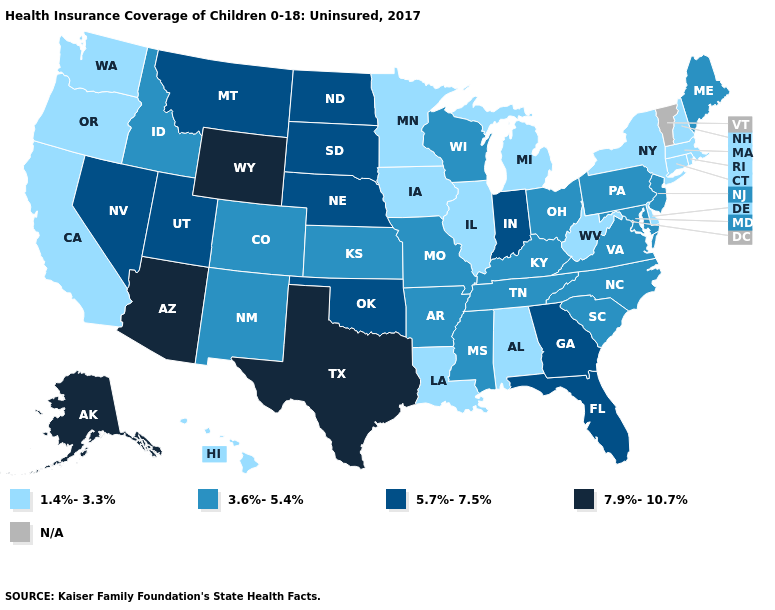Among the states that border Washington , which have the lowest value?
Be succinct. Oregon. Does New Jersey have the lowest value in the USA?
Short answer required. No. Which states have the lowest value in the MidWest?
Keep it brief. Illinois, Iowa, Michigan, Minnesota. What is the value of Michigan?
Keep it brief. 1.4%-3.3%. Does the map have missing data?
Write a very short answer. Yes. What is the value of South Carolina?
Be succinct. 3.6%-5.4%. Name the states that have a value in the range 3.6%-5.4%?
Answer briefly. Arkansas, Colorado, Idaho, Kansas, Kentucky, Maine, Maryland, Mississippi, Missouri, New Jersey, New Mexico, North Carolina, Ohio, Pennsylvania, South Carolina, Tennessee, Virginia, Wisconsin. Does Tennessee have the highest value in the USA?
Be succinct. No. Among the states that border Vermont , which have the lowest value?
Short answer required. Massachusetts, New Hampshire, New York. Name the states that have a value in the range 3.6%-5.4%?
Short answer required. Arkansas, Colorado, Idaho, Kansas, Kentucky, Maine, Maryland, Mississippi, Missouri, New Jersey, New Mexico, North Carolina, Ohio, Pennsylvania, South Carolina, Tennessee, Virginia, Wisconsin. What is the value of Minnesota?
Be succinct. 1.4%-3.3%. Name the states that have a value in the range 7.9%-10.7%?
Quick response, please. Alaska, Arizona, Texas, Wyoming. How many symbols are there in the legend?
Answer briefly. 5. Does the map have missing data?
Quick response, please. Yes. 